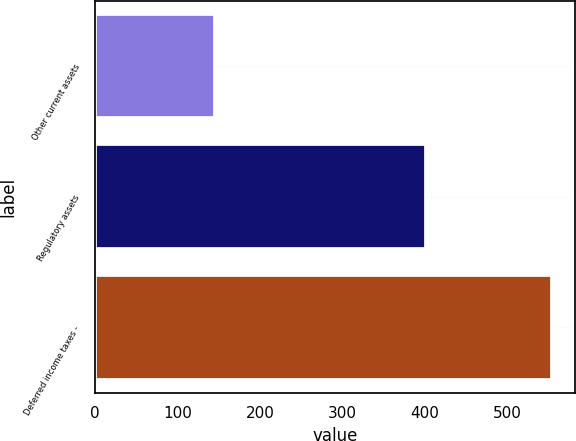Convert chart to OTSL. <chart><loc_0><loc_0><loc_500><loc_500><bar_chart><fcel>Other current assets<fcel>Regulatory assets<fcel>Deferred income taxes -<nl><fcel>145<fcel>401<fcel>554<nl></chart> 